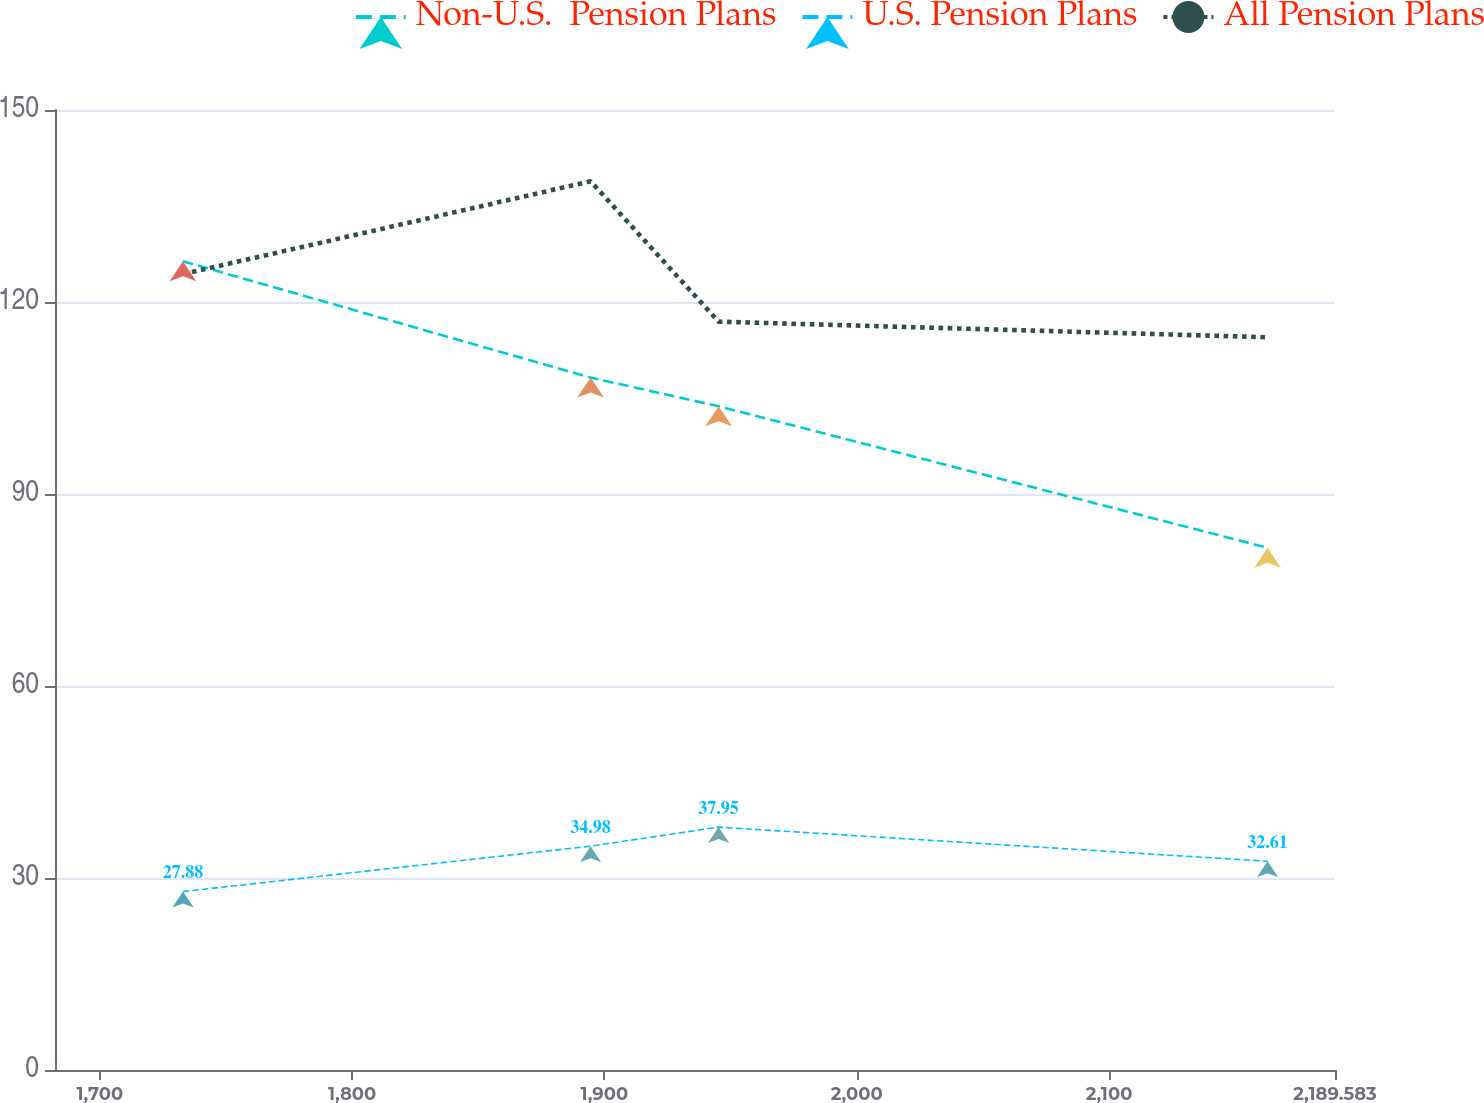<chart> <loc_0><loc_0><loc_500><loc_500><line_chart><ecel><fcel>Non-U.S.  Pension Plans<fcel>U.S. Pension Plans<fcel>All Pension Plans<nl><fcel>1732.95<fcel>126.36<fcel>27.88<fcel>124.36<nl><fcel>1894.52<fcel>108.19<fcel>34.98<fcel>138.86<nl><fcel>1945.26<fcel>103.71<fcel>37.95<fcel>116.93<nl><fcel>2162.86<fcel>81.6<fcel>32.61<fcel>114.49<nl><fcel>2240.32<fcel>91.68<fcel>26.27<fcel>128.5<nl></chart> 